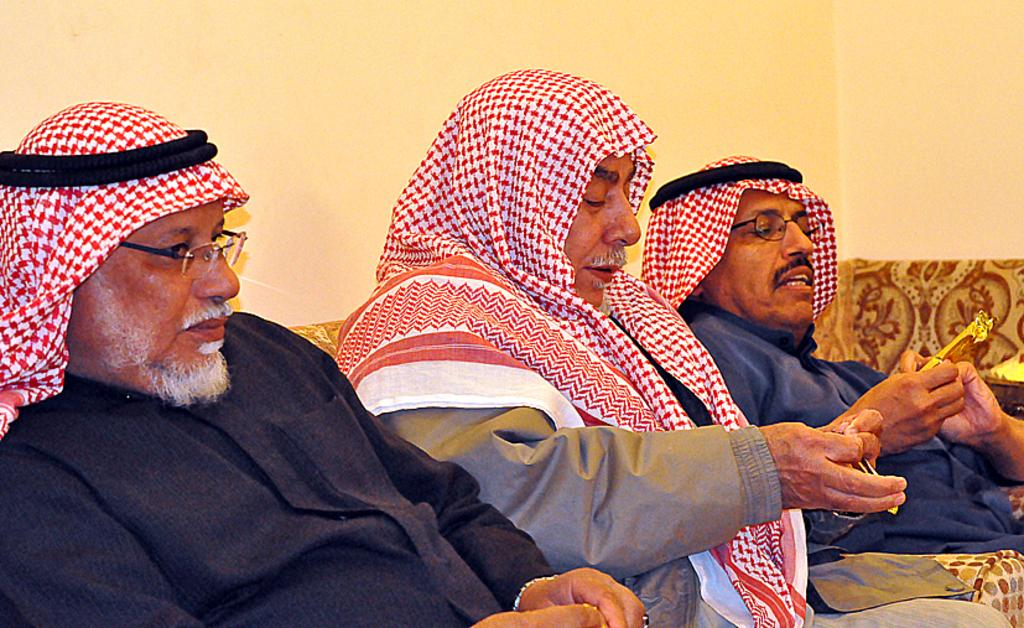How many people are in the foreground of the picture? There are three men in the foreground of the picture. What are the men doing in the picture? The men are sitting on a couch. What can be seen in the background of the picture? There is a well in the background of the picture. Are the men driving a car in the picture? No, the men are sitting on a couch in the picture, and there is no car present. 